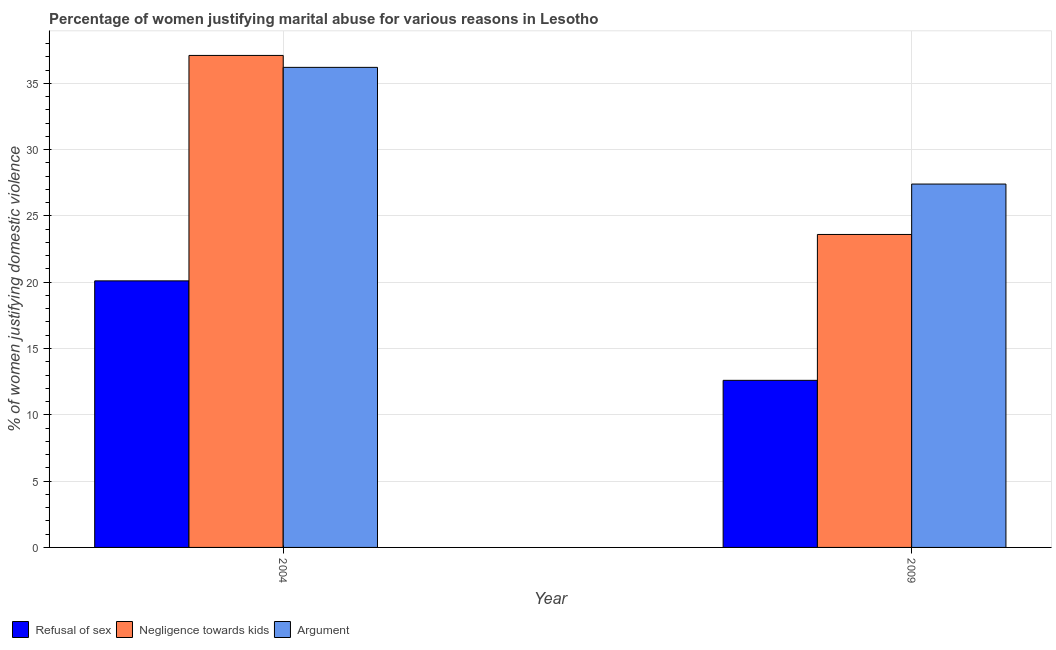Are the number of bars per tick equal to the number of legend labels?
Your response must be concise. Yes. Are the number of bars on each tick of the X-axis equal?
Keep it short and to the point. Yes. How many bars are there on the 2nd tick from the left?
Give a very brief answer. 3. How many bars are there on the 2nd tick from the right?
Provide a short and direct response. 3. What is the percentage of women justifying domestic violence due to refusal of sex in 2009?
Make the answer very short. 12.6. Across all years, what is the maximum percentage of women justifying domestic violence due to refusal of sex?
Your response must be concise. 20.1. Across all years, what is the minimum percentage of women justifying domestic violence due to negligence towards kids?
Make the answer very short. 23.6. In which year was the percentage of women justifying domestic violence due to arguments minimum?
Make the answer very short. 2009. What is the total percentage of women justifying domestic violence due to negligence towards kids in the graph?
Keep it short and to the point. 60.7. What is the difference between the percentage of women justifying domestic violence due to negligence towards kids in 2004 and that in 2009?
Your response must be concise. 13.5. What is the difference between the percentage of women justifying domestic violence due to arguments in 2009 and the percentage of women justifying domestic violence due to refusal of sex in 2004?
Your response must be concise. -8.8. What is the average percentage of women justifying domestic violence due to negligence towards kids per year?
Provide a succinct answer. 30.35. In how many years, is the percentage of women justifying domestic violence due to negligence towards kids greater than 34 %?
Provide a short and direct response. 1. What is the ratio of the percentage of women justifying domestic violence due to arguments in 2004 to that in 2009?
Your response must be concise. 1.32. Is the percentage of women justifying domestic violence due to arguments in 2004 less than that in 2009?
Make the answer very short. No. In how many years, is the percentage of women justifying domestic violence due to arguments greater than the average percentage of women justifying domestic violence due to arguments taken over all years?
Provide a succinct answer. 1. What does the 1st bar from the left in 2004 represents?
Ensure brevity in your answer.  Refusal of sex. What does the 2nd bar from the right in 2009 represents?
Your answer should be very brief. Negligence towards kids. Is it the case that in every year, the sum of the percentage of women justifying domestic violence due to refusal of sex and percentage of women justifying domestic violence due to negligence towards kids is greater than the percentage of women justifying domestic violence due to arguments?
Keep it short and to the point. Yes. How many bars are there?
Your response must be concise. 6. Are all the bars in the graph horizontal?
Offer a terse response. No. Are the values on the major ticks of Y-axis written in scientific E-notation?
Make the answer very short. No. Does the graph contain grids?
Provide a short and direct response. Yes. How are the legend labels stacked?
Make the answer very short. Horizontal. What is the title of the graph?
Your response must be concise. Percentage of women justifying marital abuse for various reasons in Lesotho. What is the label or title of the X-axis?
Your response must be concise. Year. What is the label or title of the Y-axis?
Make the answer very short. % of women justifying domestic violence. What is the % of women justifying domestic violence of Refusal of sex in 2004?
Your answer should be compact. 20.1. What is the % of women justifying domestic violence in Negligence towards kids in 2004?
Your response must be concise. 37.1. What is the % of women justifying domestic violence of Argument in 2004?
Make the answer very short. 36.2. What is the % of women justifying domestic violence in Negligence towards kids in 2009?
Your answer should be compact. 23.6. What is the % of women justifying domestic violence of Argument in 2009?
Provide a succinct answer. 27.4. Across all years, what is the maximum % of women justifying domestic violence of Refusal of sex?
Keep it short and to the point. 20.1. Across all years, what is the maximum % of women justifying domestic violence of Negligence towards kids?
Keep it short and to the point. 37.1. Across all years, what is the maximum % of women justifying domestic violence in Argument?
Your answer should be very brief. 36.2. Across all years, what is the minimum % of women justifying domestic violence in Negligence towards kids?
Provide a short and direct response. 23.6. Across all years, what is the minimum % of women justifying domestic violence of Argument?
Offer a terse response. 27.4. What is the total % of women justifying domestic violence of Refusal of sex in the graph?
Your answer should be compact. 32.7. What is the total % of women justifying domestic violence of Negligence towards kids in the graph?
Provide a short and direct response. 60.7. What is the total % of women justifying domestic violence in Argument in the graph?
Keep it short and to the point. 63.6. What is the difference between the % of women justifying domestic violence in Refusal of sex in 2004 and that in 2009?
Offer a terse response. 7.5. What is the difference between the % of women justifying domestic violence of Argument in 2004 and that in 2009?
Provide a succinct answer. 8.8. What is the average % of women justifying domestic violence in Refusal of sex per year?
Your answer should be compact. 16.35. What is the average % of women justifying domestic violence in Negligence towards kids per year?
Give a very brief answer. 30.35. What is the average % of women justifying domestic violence in Argument per year?
Keep it short and to the point. 31.8. In the year 2004, what is the difference between the % of women justifying domestic violence of Refusal of sex and % of women justifying domestic violence of Argument?
Your answer should be very brief. -16.1. In the year 2009, what is the difference between the % of women justifying domestic violence in Refusal of sex and % of women justifying domestic violence in Negligence towards kids?
Your response must be concise. -11. In the year 2009, what is the difference between the % of women justifying domestic violence of Refusal of sex and % of women justifying domestic violence of Argument?
Make the answer very short. -14.8. What is the ratio of the % of women justifying domestic violence of Refusal of sex in 2004 to that in 2009?
Ensure brevity in your answer.  1.6. What is the ratio of the % of women justifying domestic violence of Negligence towards kids in 2004 to that in 2009?
Your answer should be compact. 1.57. What is the ratio of the % of women justifying domestic violence of Argument in 2004 to that in 2009?
Your response must be concise. 1.32. What is the difference between the highest and the lowest % of women justifying domestic violence of Argument?
Give a very brief answer. 8.8. 